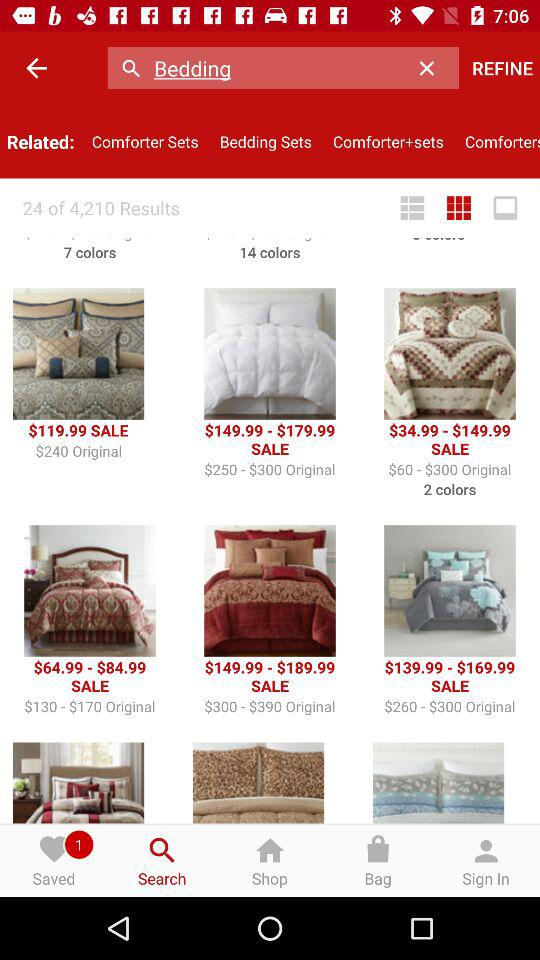How many results are shown here? There are 4210 results shown. 